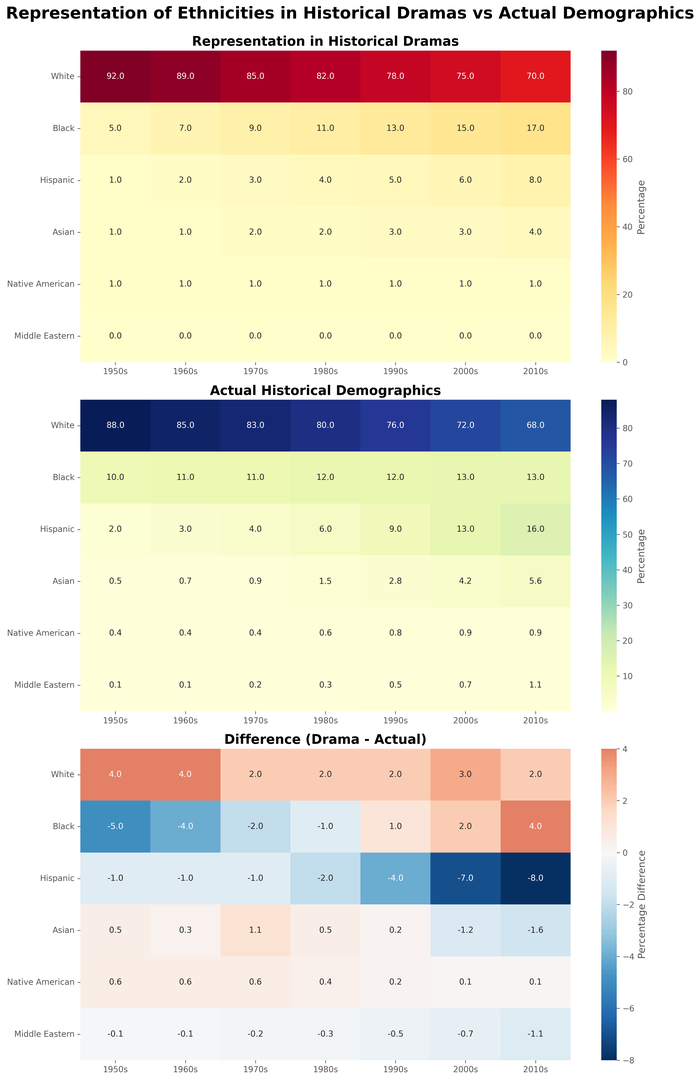What is the percentage of White representation in 2010s Dramas? First, locate the cell that corresponds to "White" in the ethnicity row and "2010s Dramas" in the columns of the first heatmap. The value in that cell is the percentage of White representation in 2010s Dramas.
Answer: 70 How does the representation of Asian characters in 1990s Dramas compare to the actual demographics of Asians in the 1990s? Compare the cell value for "Asian" in the 1990s column from the "Representation in Historical Dramas" heatmap to the corresponding value in the "Actual Historical Demographics" heatmap.
Answer: Drama: 3%, Actual: 2.8% Which ethnicity shows the biggest discrepancy between representation in Dramas and actual demographics in the 1960s? Look at the "Difference (Drama - Actual)" heatmap for the 1960s column and identify the largest value (either positive or negative).
Answer: White What is the most underrepresented ethnicity in the 2000s Dramas compared to actual demographics? Find the smallest negative value in the "Difference (Drama - Actual)" heatmap for the 2000s column.
Answer: Hispanic For which decade is the representation of Black characters in Dramas closest to the actual historical demographics? Compare the values for "Black" across all decades in the "Difference (Drama - Actual)" heatmap and identify the decade with the value closest to 0.
Answer: 1990s Calculate the average percentage difference for White representation across all decades. Sum the percentage differences for White representation across all decades from the "Difference (Drama - Actual)" heatmap, then divide by the number of decades (7).
Answer: (4 + 4 + 2 + 2 + 2 + 3 + 2) / 7 = 2.71 In which decade was Hispanic representation in Dramas most accurate compared to actual demographics? Look for the smallest absolute difference for "Hispanic" in the "Difference (Drama - Actual)" heatmap across all decades.
Answer: 1970s Of the three heatmaps, which one shows the highest overall values? Observe the color intensities and annotations across the three heatmaps to see which one generally has higher values.
Answer: Representation in Historical Dramas Which ethnicity remains nearly unchanged in both Drama representation and actual demographics across all decades? Check each ethnicity in all time periods for minimal variation between the "Representation in Historical Dramas" and "Actual Historical Demographics" heatmaps.
Answer: Native American What pattern can be observed for Middle Eastern representation from 1950s to 2010s in both Drama representation and actual demographics? Follow the trend line for "Middle Eastern" in both heatmaps and note changes across the decades.
Answer: Middle Eastern representation is absent in Dramas but increases slightly in actual demographics 